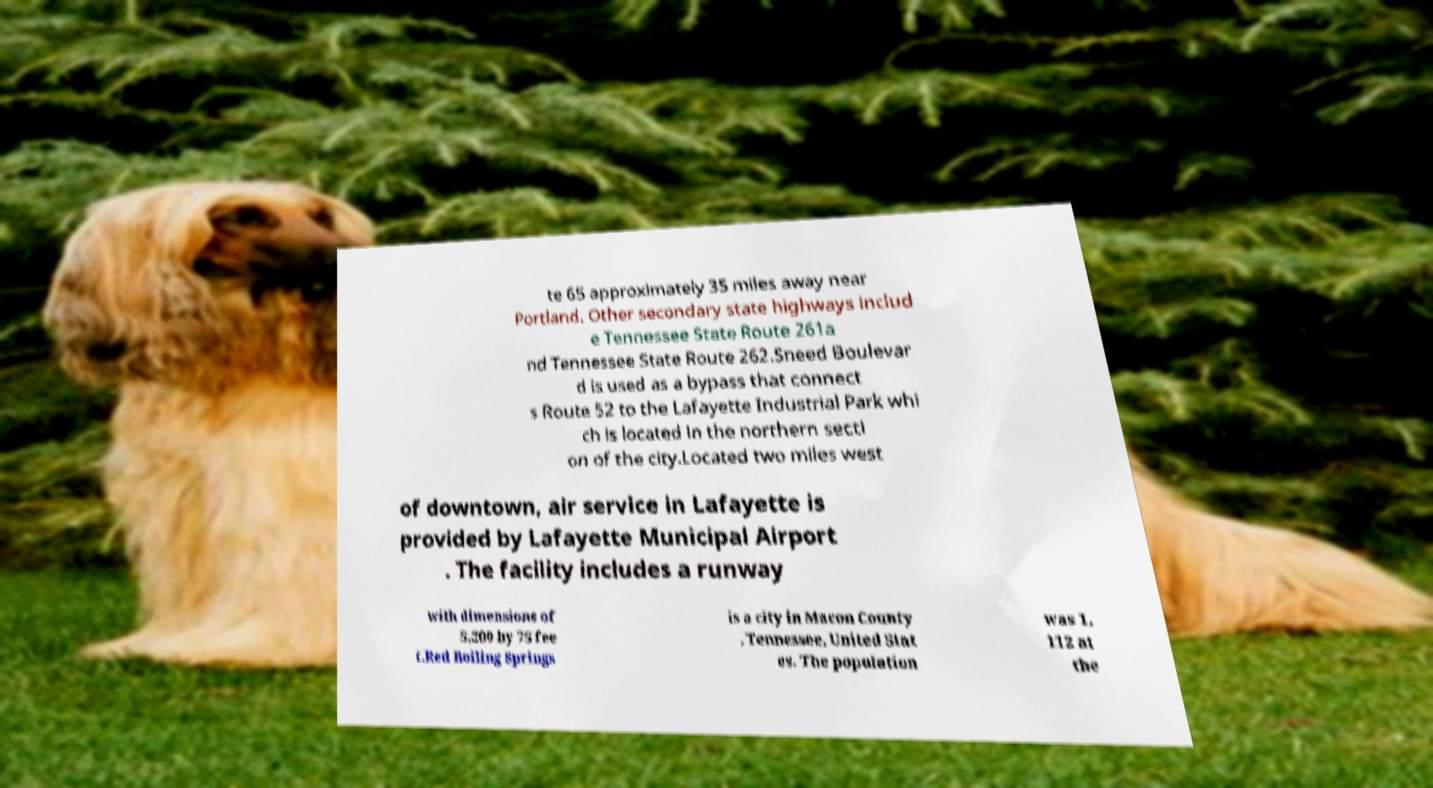Please read and relay the text visible in this image. What does it say? te 65 approximately 35 miles away near Portland. Other secondary state highways includ e Tennessee State Route 261a nd Tennessee State Route 262.Sneed Boulevar d is used as a bypass that connect s Route 52 to the Lafayette Industrial Park whi ch is located in the northern secti on of the city.Located two miles west of downtown, air service in Lafayette is provided by Lafayette Municipal Airport . The facility includes a runway with dimensions of 5,200 by 75 fee t.Red Boiling Springs is a city in Macon County , Tennessee, United Stat es. The population was 1, 112 at the 